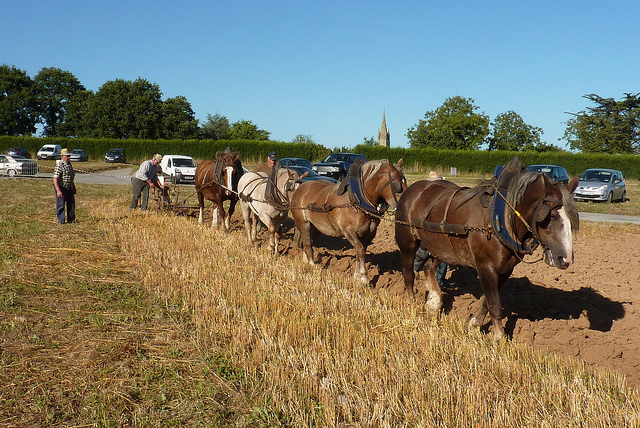<image>Where is this farm? It is ambiguous where the farm is located. It could be Pennsylvania, Texas, Scotland, Europe or America among other places. Where is this farm? I don't know where this farm is located. It can be in Pennsylvania, Texas, Scotland, Europe, or even in Timbuktu. 